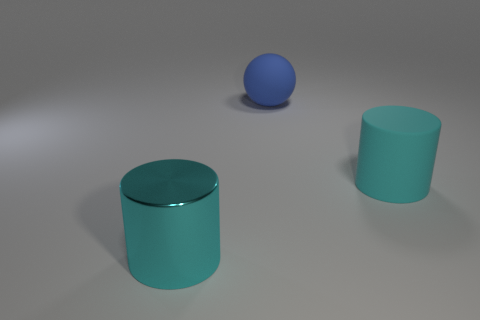There is a large thing that is on the left side of the large cyan rubber cylinder and in front of the blue rubber object; what material is it?
Provide a short and direct response. Metal. There is a metallic object that is the same size as the blue ball; what color is it?
Ensure brevity in your answer.  Cyan. Is the sphere made of the same material as the cyan object that is behind the large metallic object?
Make the answer very short. Yes. How many other objects are the same size as the metal cylinder?
Give a very brief answer. 2. Is there a cyan rubber cylinder to the left of the large cyan cylinder that is in front of the big cyan object right of the big metallic object?
Your answer should be compact. No. What size is the shiny thing?
Your answer should be very brief. Large. There is a cyan cylinder that is left of the blue thing; what size is it?
Your response must be concise. Large. Is the size of the matte object that is in front of the blue sphere the same as the large blue sphere?
Your answer should be very brief. Yes. Are there any other things of the same color as the shiny cylinder?
Make the answer very short. Yes. What is the shape of the large cyan matte thing?
Offer a very short reply. Cylinder. 